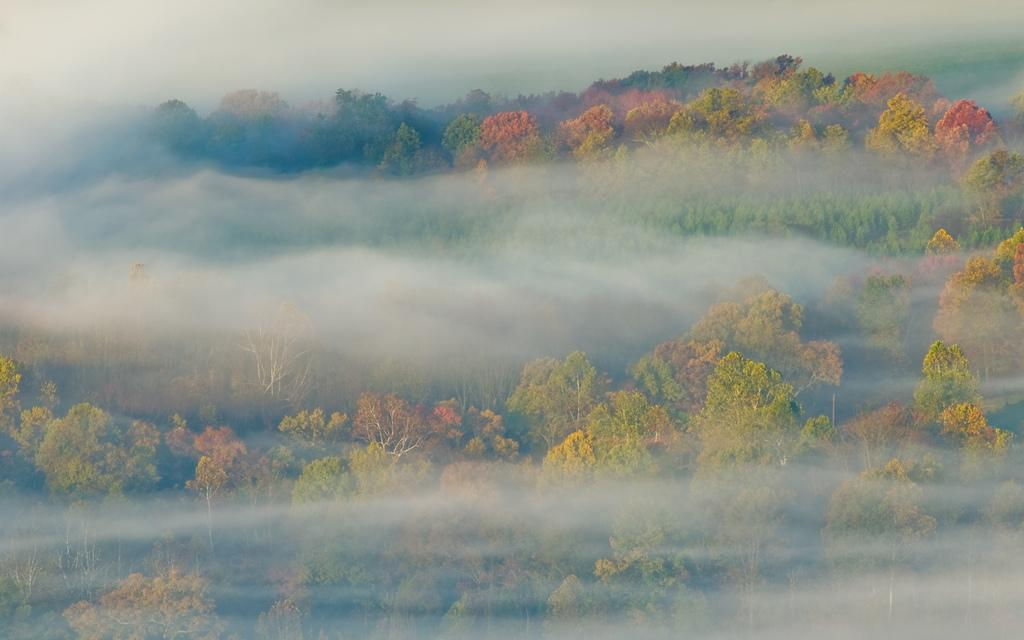What can be seen in the sky in the image? There are clouds visible in the image. What type of vegetation can be seen in the image? There are trees visible in the image. How many cattle are grazing in the town in the image? There are no cattle or town present in the image; it features clouds and trees. What type of plough is being used by the farmers in the image? There are no farmers or ploughs present in the image. 